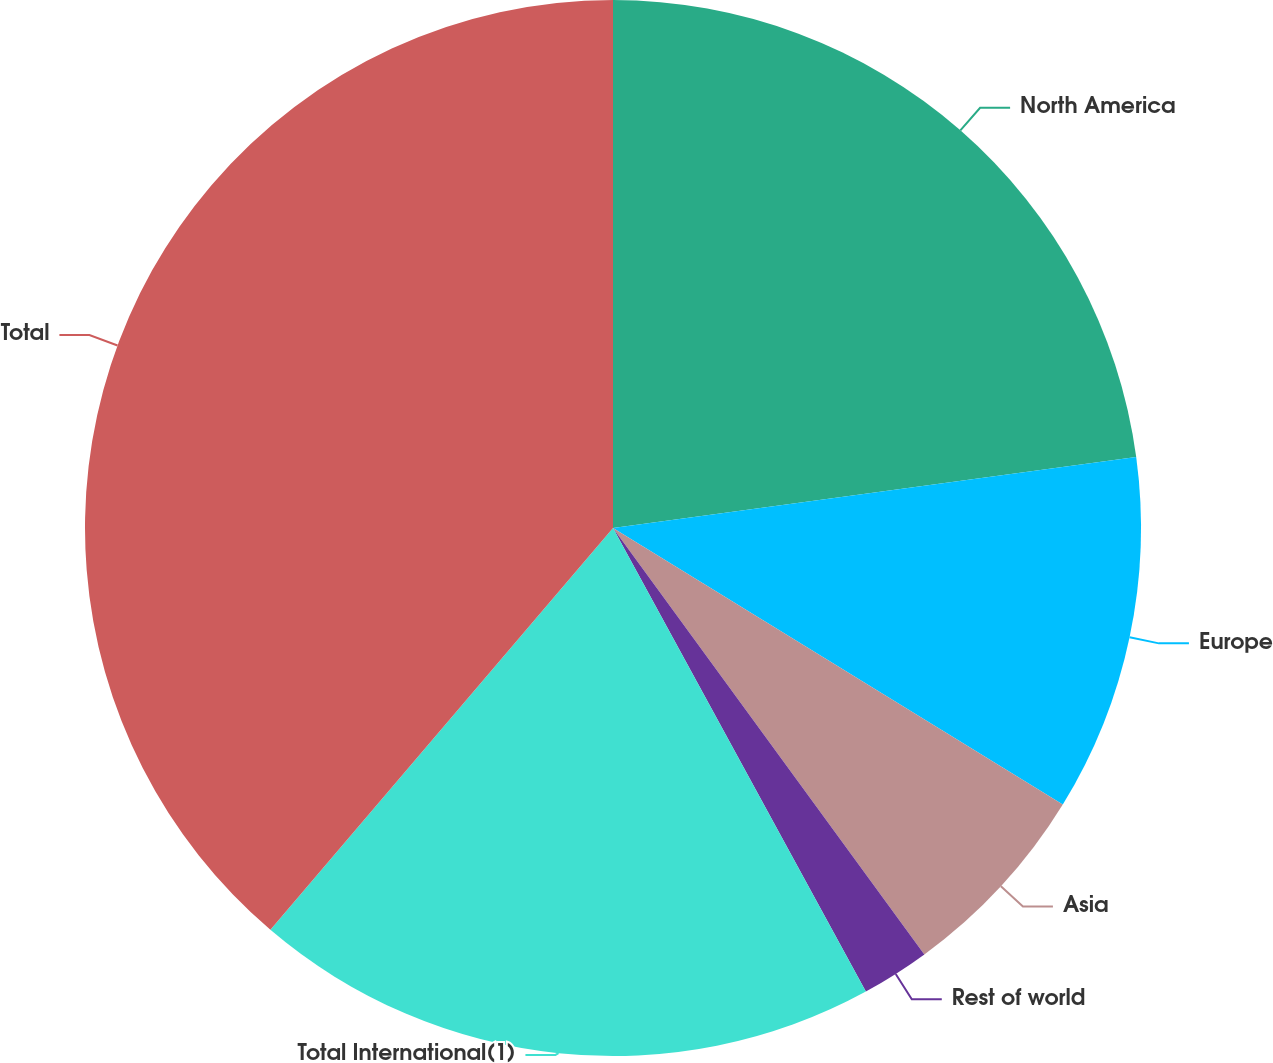Convert chart. <chart><loc_0><loc_0><loc_500><loc_500><pie_chart><fcel>North America<fcel>Europe<fcel>Asia<fcel>Rest of world<fcel>Total International(1)<fcel>Total<nl><fcel>22.86%<fcel>10.92%<fcel>6.19%<fcel>2.09%<fcel>19.19%<fcel>38.77%<nl></chart> 